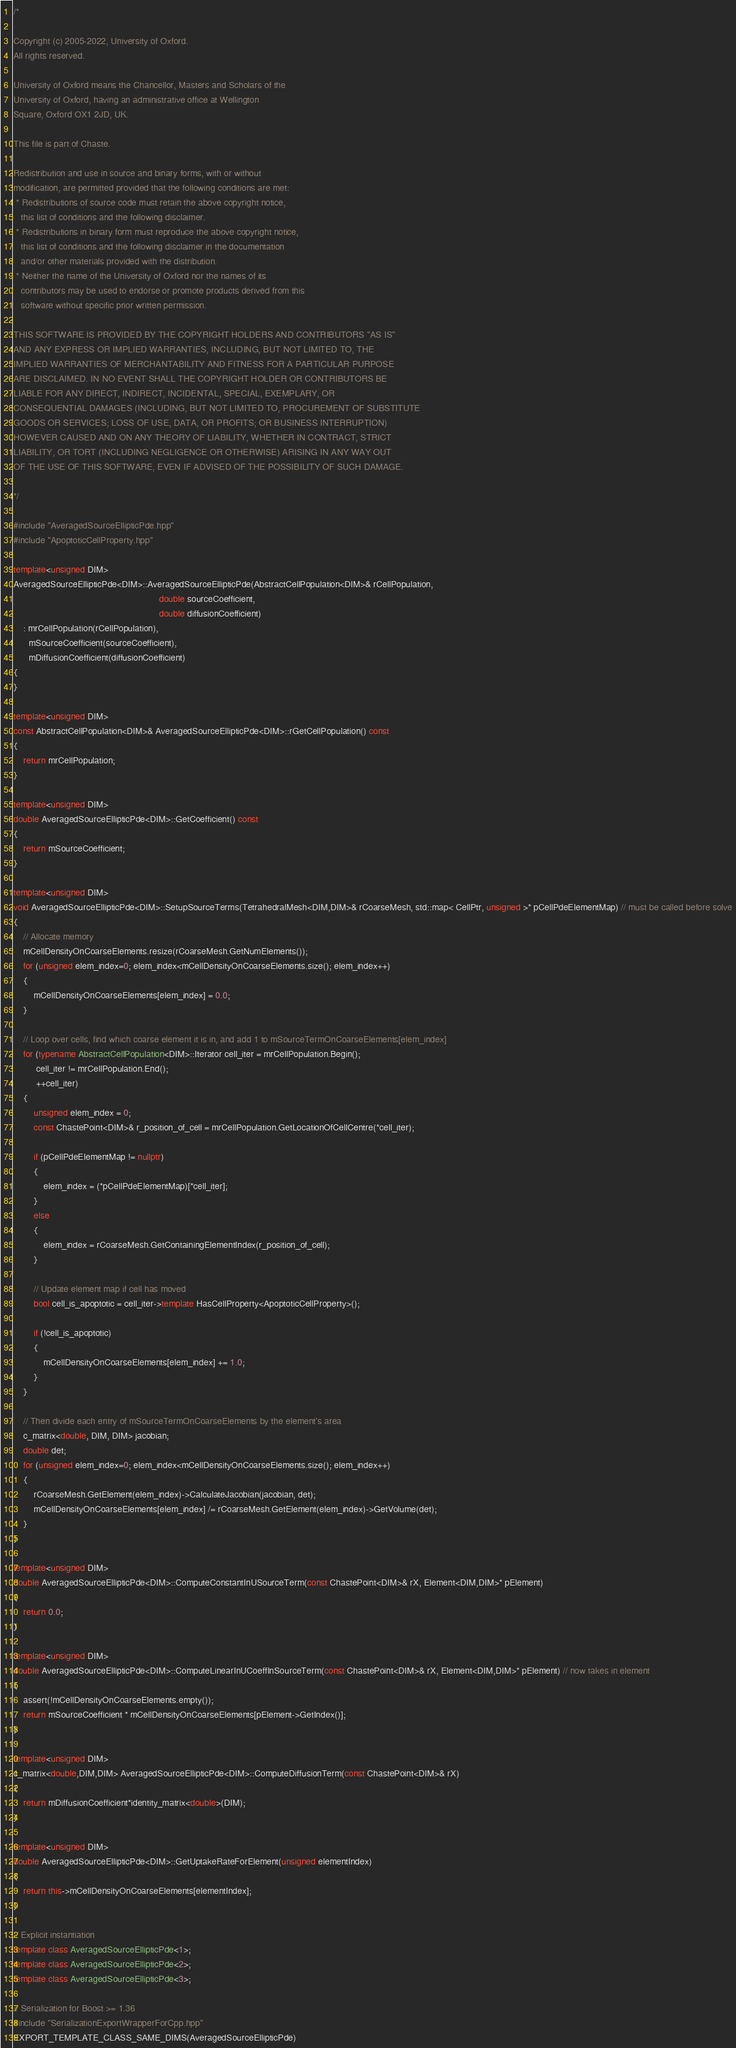Convert code to text. <code><loc_0><loc_0><loc_500><loc_500><_C++_>/*

Copyright (c) 2005-2022, University of Oxford.
All rights reserved.

University of Oxford means the Chancellor, Masters and Scholars of the
University of Oxford, having an administrative office at Wellington
Square, Oxford OX1 2JD, UK.

This file is part of Chaste.

Redistribution and use in source and binary forms, with or without
modification, are permitted provided that the following conditions are met:
 * Redistributions of source code must retain the above copyright notice,
   this list of conditions and the following disclaimer.
 * Redistributions in binary form must reproduce the above copyright notice,
   this list of conditions and the following disclaimer in the documentation
   and/or other materials provided with the distribution.
 * Neither the name of the University of Oxford nor the names of its
   contributors may be used to endorse or promote products derived from this
   software without specific prior written permission.

THIS SOFTWARE IS PROVIDED BY THE COPYRIGHT HOLDERS AND CONTRIBUTORS "AS IS"
AND ANY EXPRESS OR IMPLIED WARRANTIES, INCLUDING, BUT NOT LIMITED TO, THE
IMPLIED WARRANTIES OF MERCHANTABILITY AND FITNESS FOR A PARTICULAR PURPOSE
ARE DISCLAIMED. IN NO EVENT SHALL THE COPYRIGHT HOLDER OR CONTRIBUTORS BE
LIABLE FOR ANY DIRECT, INDIRECT, INCIDENTAL, SPECIAL, EXEMPLARY, OR
CONSEQUENTIAL DAMAGES (INCLUDING, BUT NOT LIMITED TO, PROCUREMENT OF SUBSTITUTE
GOODS OR SERVICES; LOSS OF USE, DATA, OR PROFITS; OR BUSINESS INTERRUPTION)
HOWEVER CAUSED AND ON ANY THEORY OF LIABILITY, WHETHER IN CONTRACT, STRICT
LIABILITY, OR TORT (INCLUDING NEGLIGENCE OR OTHERWISE) ARISING IN ANY WAY OUT
OF THE USE OF THIS SOFTWARE, EVEN IF ADVISED OF THE POSSIBILITY OF SUCH DAMAGE.

*/

#include "AveragedSourceEllipticPde.hpp"
#include "ApoptoticCellProperty.hpp"

template<unsigned DIM>
AveragedSourceEllipticPde<DIM>::AveragedSourceEllipticPde(AbstractCellPopulation<DIM>& rCellPopulation,
                                                          double sourceCoefficient,
                                                          double diffusionCoefficient)
    : mrCellPopulation(rCellPopulation),
      mSourceCoefficient(sourceCoefficient),
      mDiffusionCoefficient(diffusionCoefficient)
{
}

template<unsigned DIM>
const AbstractCellPopulation<DIM>& AveragedSourceEllipticPde<DIM>::rGetCellPopulation() const
{
    return mrCellPopulation;
}

template<unsigned DIM>
double AveragedSourceEllipticPde<DIM>::GetCoefficient() const
{
    return mSourceCoefficient;
}

template<unsigned DIM>
void AveragedSourceEllipticPde<DIM>::SetupSourceTerms(TetrahedralMesh<DIM,DIM>& rCoarseMesh, std::map< CellPtr, unsigned >* pCellPdeElementMap) // must be called before solve
{
    // Allocate memory
    mCellDensityOnCoarseElements.resize(rCoarseMesh.GetNumElements());
    for (unsigned elem_index=0; elem_index<mCellDensityOnCoarseElements.size(); elem_index++)
    {
        mCellDensityOnCoarseElements[elem_index] = 0.0;
    }

    // Loop over cells, find which coarse element it is in, and add 1 to mSourceTermOnCoarseElements[elem_index]
    for (typename AbstractCellPopulation<DIM>::Iterator cell_iter = mrCellPopulation.Begin();
         cell_iter != mrCellPopulation.End();
         ++cell_iter)
    {
        unsigned elem_index = 0;
        const ChastePoint<DIM>& r_position_of_cell = mrCellPopulation.GetLocationOfCellCentre(*cell_iter);

        if (pCellPdeElementMap != nullptr)
        {
            elem_index = (*pCellPdeElementMap)[*cell_iter];
        }
        else
        {
            elem_index = rCoarseMesh.GetContainingElementIndex(r_position_of_cell);
        }

        // Update element map if cell has moved
        bool cell_is_apoptotic = cell_iter->template HasCellProperty<ApoptoticCellProperty>();

        if (!cell_is_apoptotic)
        {
            mCellDensityOnCoarseElements[elem_index] += 1.0;
        }
    }

    // Then divide each entry of mSourceTermOnCoarseElements by the element's area
    c_matrix<double, DIM, DIM> jacobian;
    double det;
    for (unsigned elem_index=0; elem_index<mCellDensityOnCoarseElements.size(); elem_index++)
    {
        rCoarseMesh.GetElement(elem_index)->CalculateJacobian(jacobian, det);
        mCellDensityOnCoarseElements[elem_index] /= rCoarseMesh.GetElement(elem_index)->GetVolume(det);
    }
}

template<unsigned DIM>
double AveragedSourceEllipticPde<DIM>::ComputeConstantInUSourceTerm(const ChastePoint<DIM>& rX, Element<DIM,DIM>* pElement)
{
    return 0.0;
}

template<unsigned DIM>
double AveragedSourceEllipticPde<DIM>::ComputeLinearInUCoeffInSourceTerm(const ChastePoint<DIM>& rX, Element<DIM,DIM>* pElement) // now takes in element
{
    assert(!mCellDensityOnCoarseElements.empty());
    return mSourceCoefficient * mCellDensityOnCoarseElements[pElement->GetIndex()];
}

template<unsigned DIM>
c_matrix<double,DIM,DIM> AveragedSourceEllipticPde<DIM>::ComputeDiffusionTerm(const ChastePoint<DIM>& rX)
{
    return mDiffusionCoefficient*identity_matrix<double>(DIM);
}

template<unsigned DIM>
double AveragedSourceEllipticPde<DIM>::GetUptakeRateForElement(unsigned elementIndex)
{
    return this->mCellDensityOnCoarseElements[elementIndex];
}

// Explicit instantiation
template class AveragedSourceEllipticPde<1>;
template class AveragedSourceEllipticPde<2>;
template class AveragedSourceEllipticPde<3>;

// Serialization for Boost >= 1.36
#include "SerializationExportWrapperForCpp.hpp"
EXPORT_TEMPLATE_CLASS_SAME_DIMS(AveragedSourceEllipticPde)
</code> 